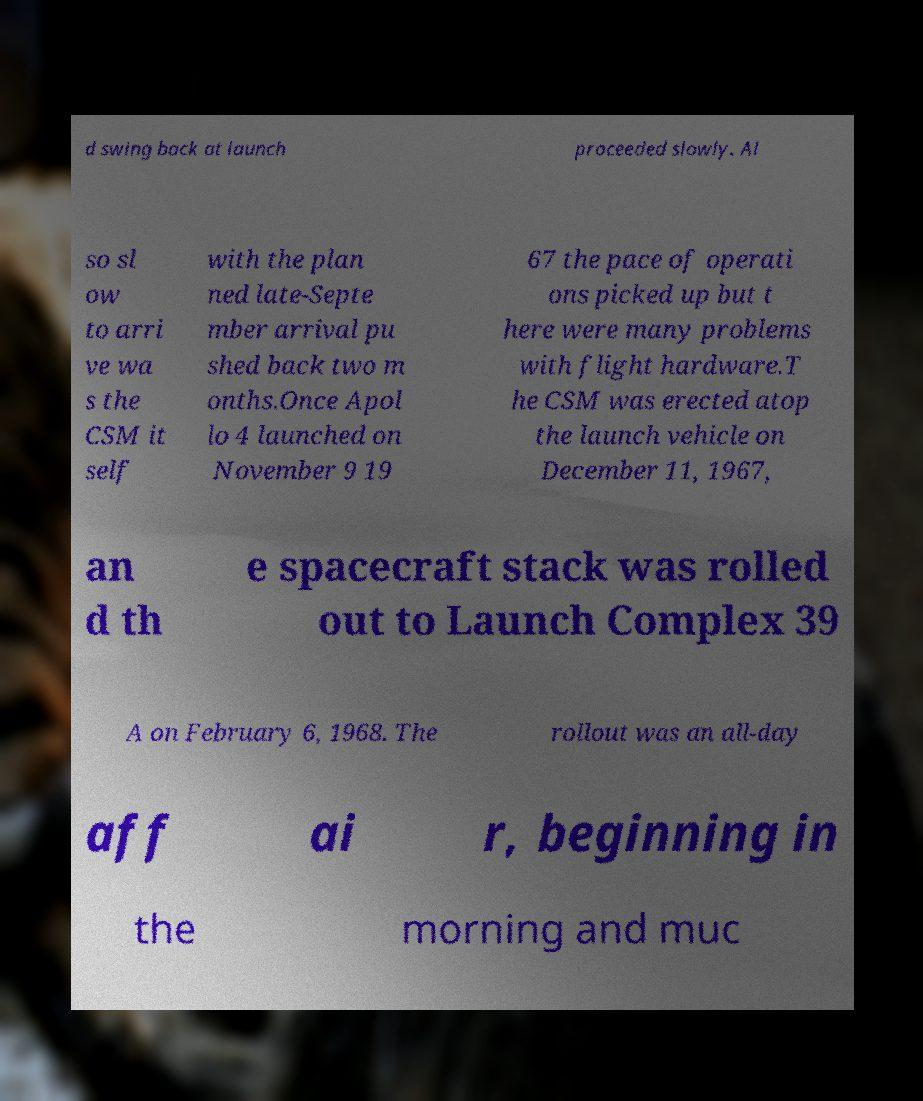There's text embedded in this image that I need extracted. Can you transcribe it verbatim? d swing back at launch proceeded slowly. Al so sl ow to arri ve wa s the CSM it self with the plan ned late-Septe mber arrival pu shed back two m onths.Once Apol lo 4 launched on November 9 19 67 the pace of operati ons picked up but t here were many problems with flight hardware.T he CSM was erected atop the launch vehicle on December 11, 1967, an d th e spacecraft stack was rolled out to Launch Complex 39 A on February 6, 1968. The rollout was an all-day aff ai r, beginning in the morning and muc 